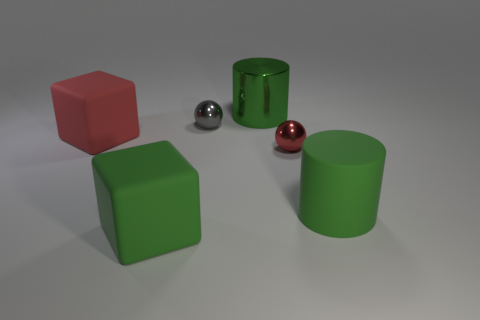There is a rubber object that is the same color as the large rubber cylinder; what is its shape?
Provide a succinct answer. Cube. How many things are either green objects that are on the right side of the small gray metal ball or green cylinders?
Provide a succinct answer. 2. How many other objects are the same shape as the small gray shiny object?
Keep it short and to the point. 1. What number of yellow things are either metal balls or shiny cylinders?
Provide a succinct answer. 0. There is a small object that is the same material as the tiny gray ball; what color is it?
Ensure brevity in your answer.  Red. Is the material of the small sphere right of the green metal thing the same as the big thing behind the gray metallic object?
Your answer should be very brief. Yes. What is the size of the other cylinder that is the same color as the metal cylinder?
Make the answer very short. Large. What material is the sphere behind the red block?
Make the answer very short. Metal. There is a metal object in front of the red matte block; is its shape the same as the green object that is behind the tiny red object?
Make the answer very short. No. There is another cylinder that is the same color as the matte cylinder; what is it made of?
Provide a short and direct response. Metal. 